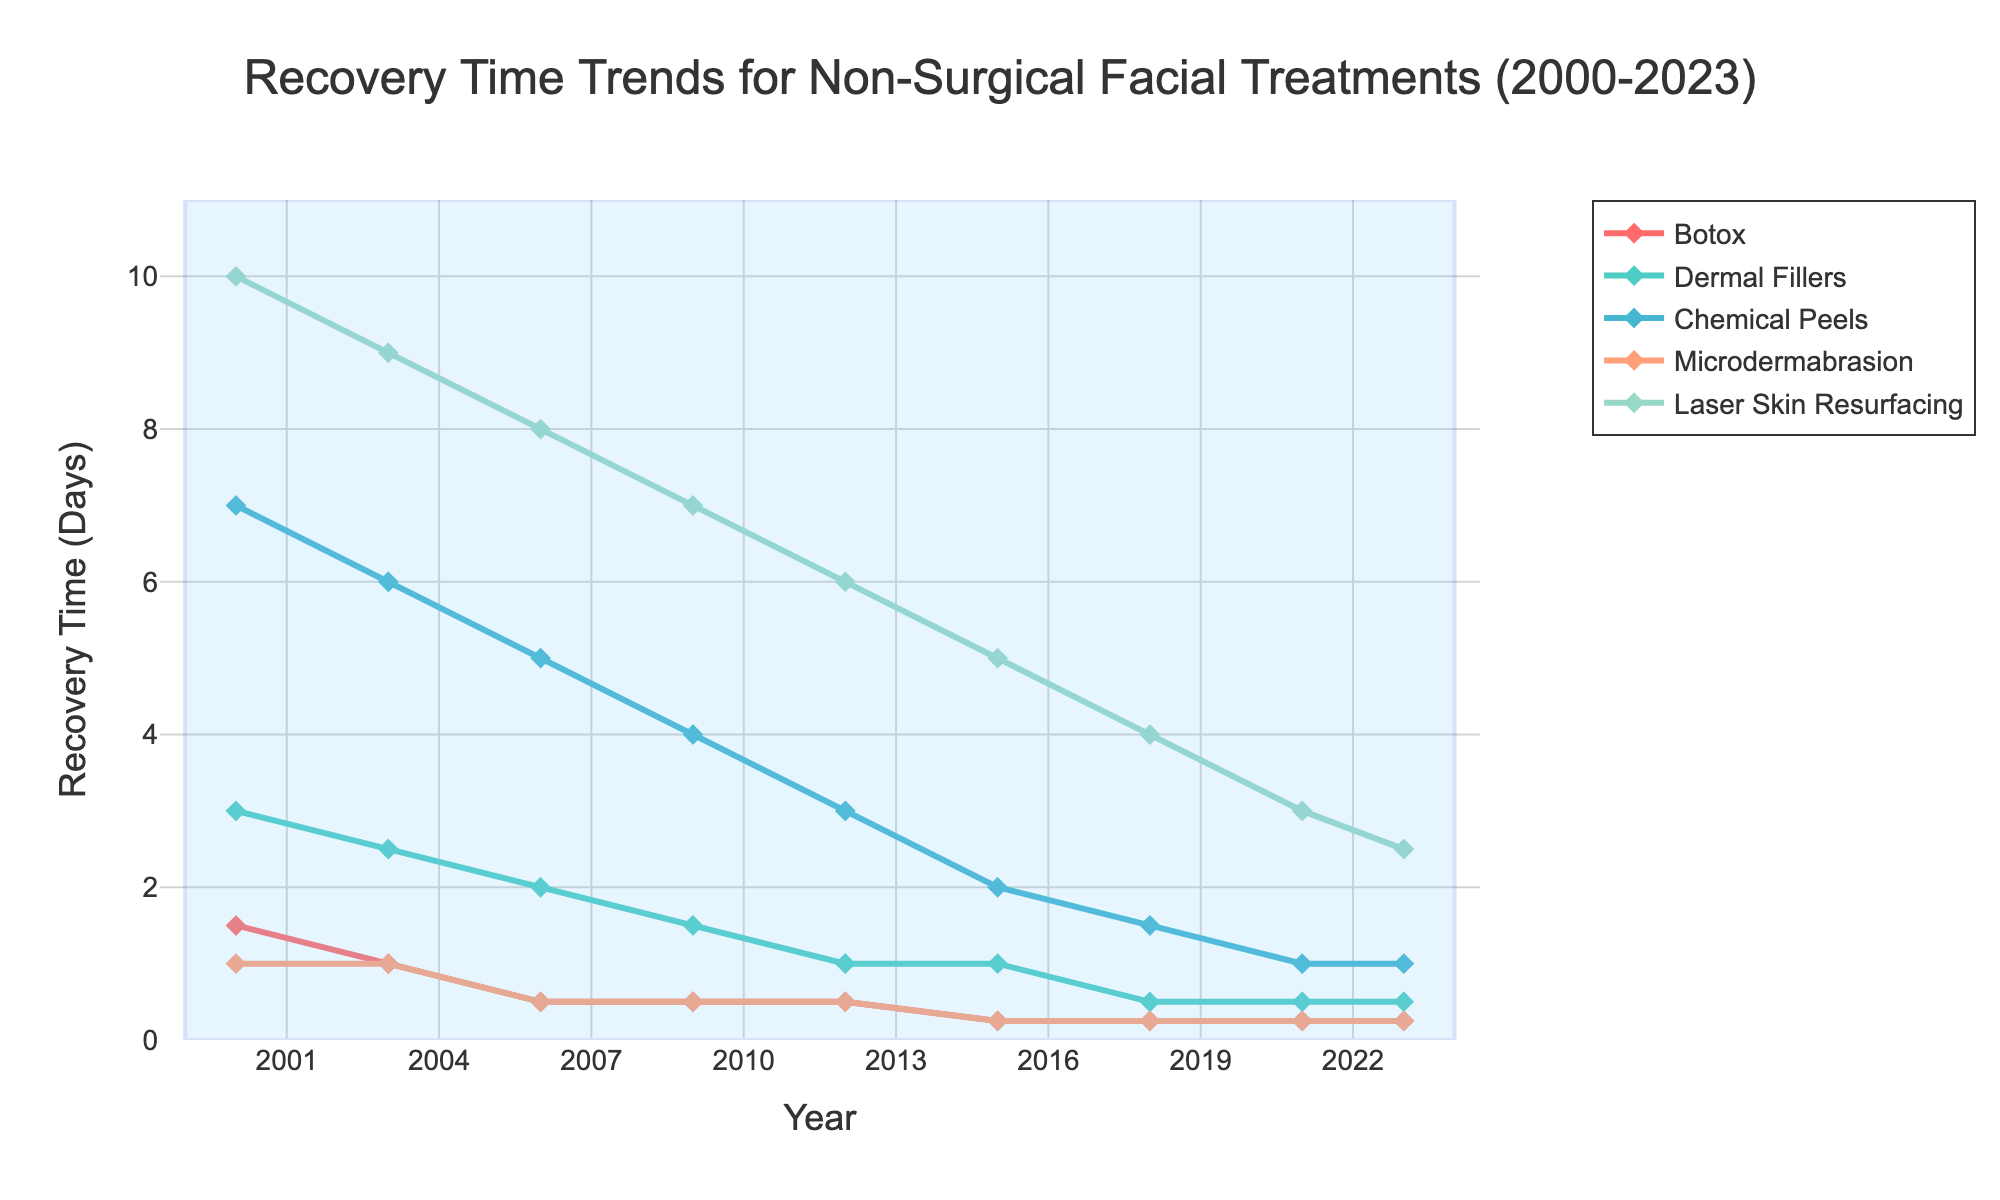Which treatment had the shortest recovery time throughout the entire period? To find the treatment with the shortest recovery time consistently, look at each procedure's line and see which one has the lowest values from 2000 to 2023. Botox always either has the lowest or ties for the lowest recovery times, thus it consistently has the shortest recovery time.
Answer: Botox How much did the recovery time for Chemical Peels decrease from 2000 to 2023? Subtract the recovery time for Chemical Peels in 2023 from the recovery time in 2000, which are 7 days and 1 day respectively. So, 7 - 1 = 6 days.
Answer: 6 days Which two treatments had the same recovery time in 2023? By examining the data points in 2023, Dermal Fillers and Chemical Peels both have a recovery time of 0.5 days.
Answer: Dermal Fillers and Chemical Peels How does the recovery time trend for Laser Skin Resurfacing compare to Microdermabrasion from 2000 to 2023? Start by comparing the initial and final recovery times, then observe the trend lines over the period. Laser Skin Resurfacing starts at 10 days and ends at 2.5 days, decreasing, while Microdermabrasion starts at 1 day and remains constant at 0.25 days from 2006 onwards.
Answer: Laser Skin Resurfacing decreased more significantly than Microdermabrasion What is the average recovery time for Dermal Fillers over the entire period? Average is calculated by summing up all the recovery times for Dermal Fillers and dividing by the number of recorded years. The sum is 3 + 2.5 + 2 + 1.5 + 1 + 1 + 0.5 + 0.5 + 0.5 = 12.5. The number of years is 9, so the average is 12.5 / 9 ≈ 1.39 days.
Answer: 1.39 days Which treatment showed the fastest recovery time improvement? By comparing the relative changes in recovery times, Laser Skin Resurfacing shows the most significant improvement, from 10 days to 2.5 days. It decreased by 7.5 days, which is the largest absolute decrease among all treatments.
Answer: Laser Skin Resurfacing In which year did Botox achieve its minimum recovery time? Scan the plot for the lowest point in the Botox line, which is first reached in 2006 when it reduced to 0.5 days from the previous 1 day.
Answer: 2006 Is recovery time for Chemical Peels less than that of Microdermabrasion in 2023? Look at the data for both treatments in 2023. Chemical Peels have a recovery time of 1 day, while Microdermabrasion has 0.25 days, which is less.
Answer: No If I want the fastest recovery treatment as of 2023, which one should I choose? Based on the data for 2023, Botox, Microdermabrasion, and Laser Skin Resurfacing all have the recovery time of 0.25 days.
Answer: Botox, Microdermabrasion, or Laser Skin Resurfacing What is the trend of recovery time for Dermal Fillers from 2000 to 2023? Observing the line for Dermal Fillers, it shows a steady decline from 3 days in 2000 to 0.5 days in 2023.
Answer: Steady decrease 